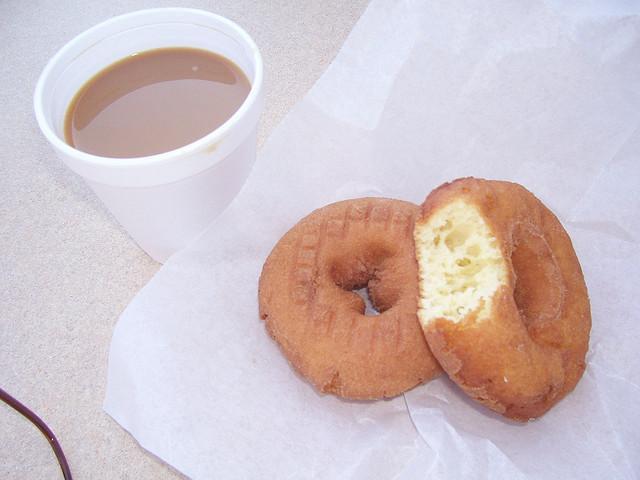How many donuts are pictured?
Give a very brief answer. 2. How many donuts are there?
Give a very brief answer. 2. 